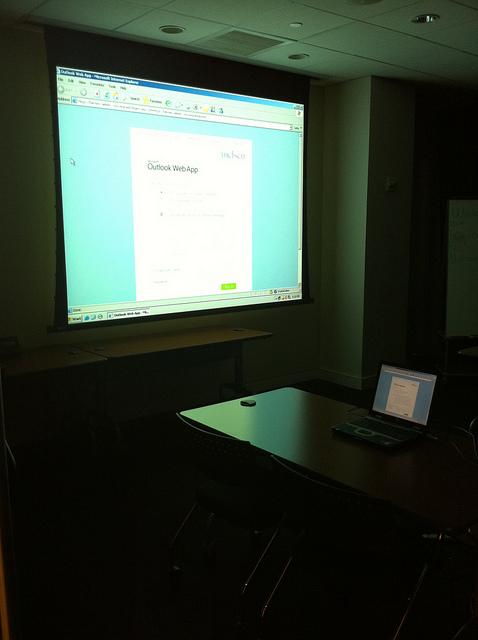What does the green light, on the TV, indicate?
Concise answer only. Background. Is the light on?
Give a very brief answer. No. What room of the house is this?
Keep it brief. Office. What is the size of the TV?
Give a very brief answer. Large. Is the room messy?
Keep it brief. No. Is this a TV screen?
Be succinct. Yes. How big is the TV?
Answer briefly. Very big. What companion object to the TV can be seen in the bottom right of the picture?
Quick response, please. Laptop. What is the small computer on the left called?
Short answer required. Laptop. What is above the TV?
Give a very brief answer. Vent. What is on the display?
Keep it brief. Document. Is there a laptop in the image?
Be succinct. Yes. Is it a monitor or a screen projection?
Answer briefly. Screen projection. What is on the TV screen?
Answer briefly. Document. What is the title of the presentation in the picture?
Write a very short answer. Outlook web app. 